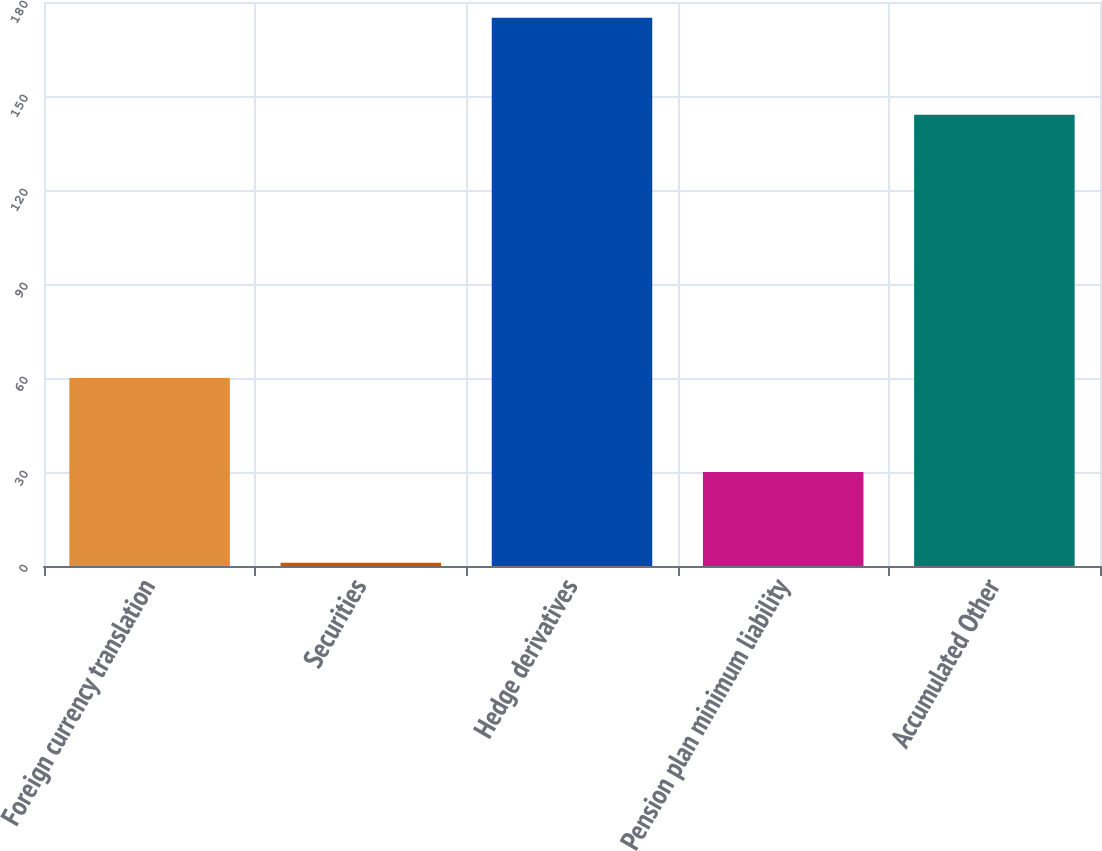Convert chart. <chart><loc_0><loc_0><loc_500><loc_500><bar_chart><fcel>Foreign currency translation<fcel>Securities<fcel>Hedge derivatives<fcel>Pension plan minimum liability<fcel>Accumulated Other<nl><fcel>60<fcel>1<fcel>175<fcel>30<fcel>144<nl></chart> 